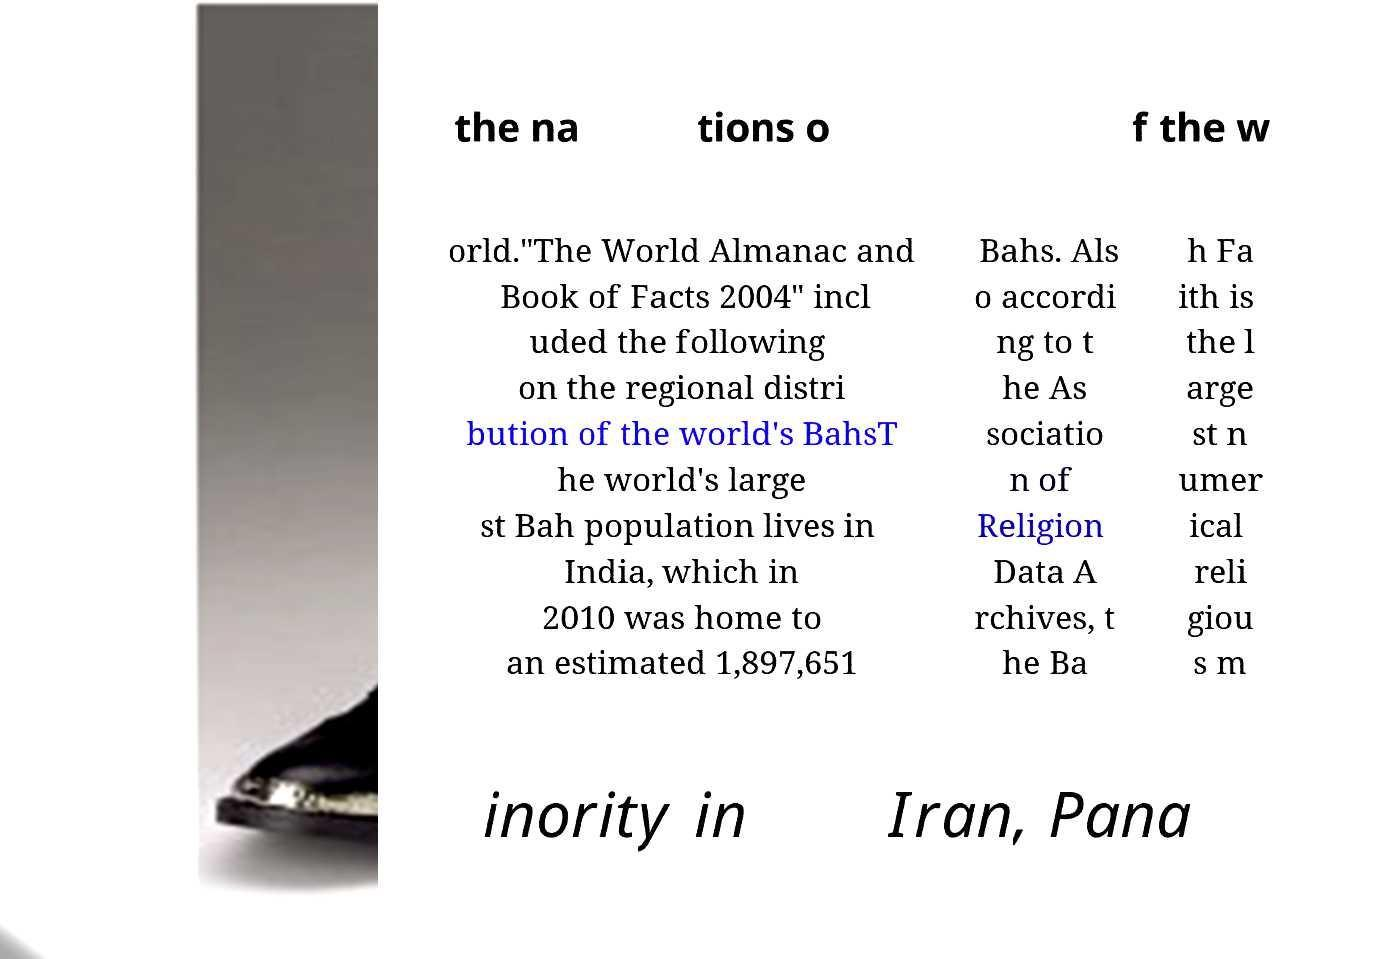For documentation purposes, I need the text within this image transcribed. Could you provide that? the na tions o f the w orld."The World Almanac and Book of Facts 2004" incl uded the following on the regional distri bution of the world's BahsT he world's large st Bah population lives in India, which in 2010 was home to an estimated 1,897,651 Bahs. Als o accordi ng to t he As sociatio n of Religion Data A rchives, t he Ba h Fa ith is the l arge st n umer ical reli giou s m inority in Iran, Pana 